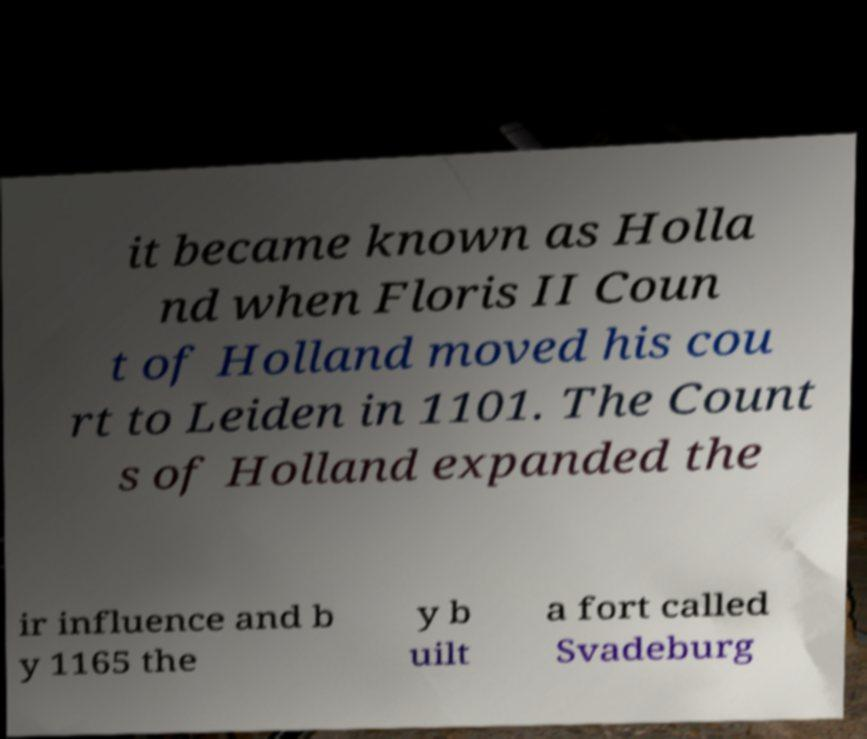For documentation purposes, I need the text within this image transcribed. Could you provide that? it became known as Holla nd when Floris II Coun t of Holland moved his cou rt to Leiden in 1101. The Count s of Holland expanded the ir influence and b y 1165 the y b uilt a fort called Svadeburg 